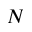<formula> <loc_0><loc_0><loc_500><loc_500>N</formula> 